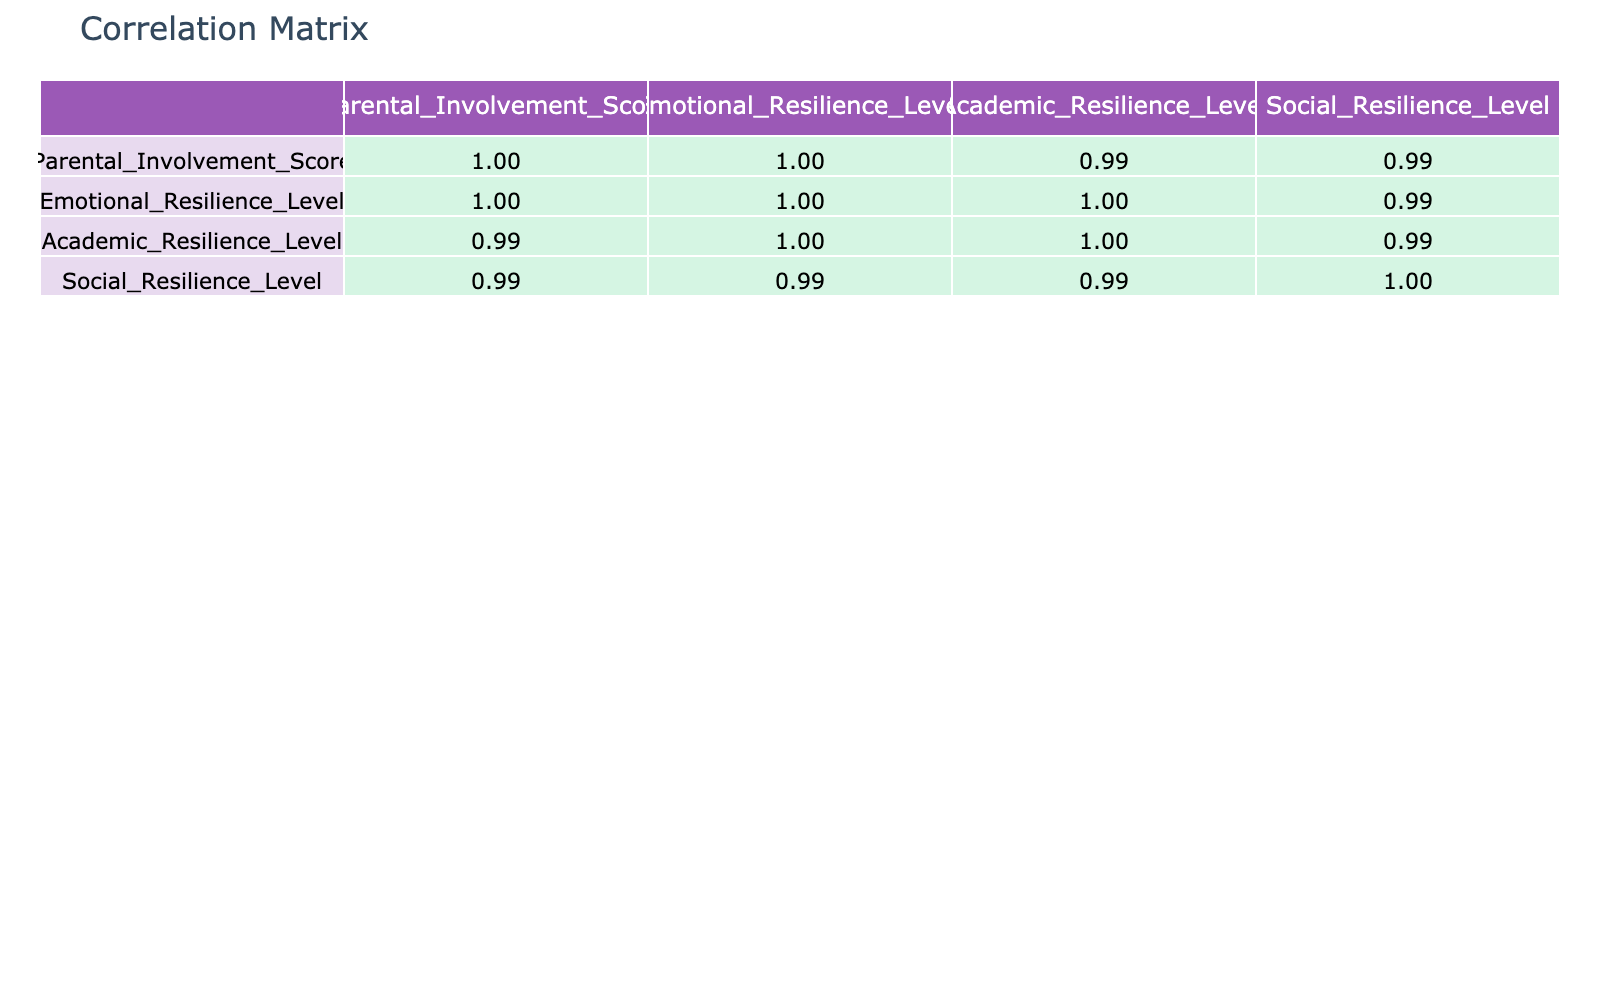What is the correlation between parental involvement score and emotional resilience level? Looking at the correlation matrix, the correlation coefficient between the parental involvement score and emotional resilience level is 0.91. This means there is a strong positive correlation.
Answer: 0.91 What is the lowest social resilience level recorded? The table shows the social resilience levels, with the lowest value being 54, which corresponds to a parental involvement score of 60.
Answer: 54 What is the average emotional resilience level of the children? To find the average emotional resilience level, we sum the values (78 + 85 + 65 + 90 + 75 + 70 + 84 + 89 + 55 + 61) =  70.5, and then divide by the number of data points (10). Therefore, the average is 77.
Answer: 77 Is the correlation between parental involvement and academic resilience positive or negative? Referring to the correlation matrix, we can see that the correlation coefficient between parental involvement and academic resilience level is 0.93, indicating a positive correlation.
Answer: Positive Which resilience level shows the highest correlation with parental involvement? By examining the correlation coefficients in the table, emotional resilience (0.91) and academic resilience (0.93) are noted. The academic resilience level shows the highest correlation with a coefficient of 0.93.
Answer: Academic resilience level What is the difference between the maximum and minimum emotional resilience levels? The maximum emotional resilience level observed is 90 (at a parental involvement score of 95) and the minimum is 55 (at a parental involvement score of 60). Thus, the difference is 90 - 55 = 35.
Answer: 35 Does a parental involvement score of 88 correspond to a higher emotional resilience level than a score of 75? Yes. The emotional resilience level for a parental involvement score of 88 is 84, while for a score of 75, it is 70. Therefore, 84 > 70 confirms this.
Answer: Yes What is the correlation between emotional resilience level and social resilience level? The correlation coefficient between emotional resilience level and social resilience level shown in the table is 0.86, indicating a strong positive correlation.
Answer: 0.86 What is the average parental involvement score for children with resilience levels above 80? The parental involvement scores for children with emotional, academic, and social resilience above 80 are 85, 90, 95, 88, and 92. Summing these gives 85 + 90 + 95 + 88 + 92 = 450. Dividing by the number of samples (5), the average is 90.
Answer: 90 